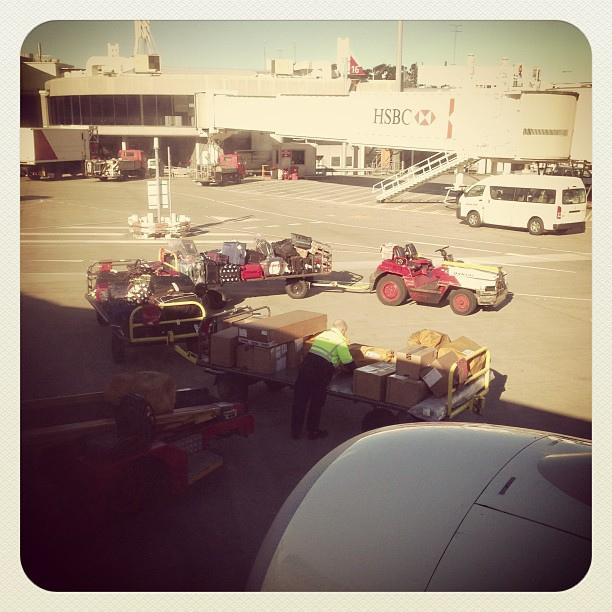What is the big item in the far back right? van 